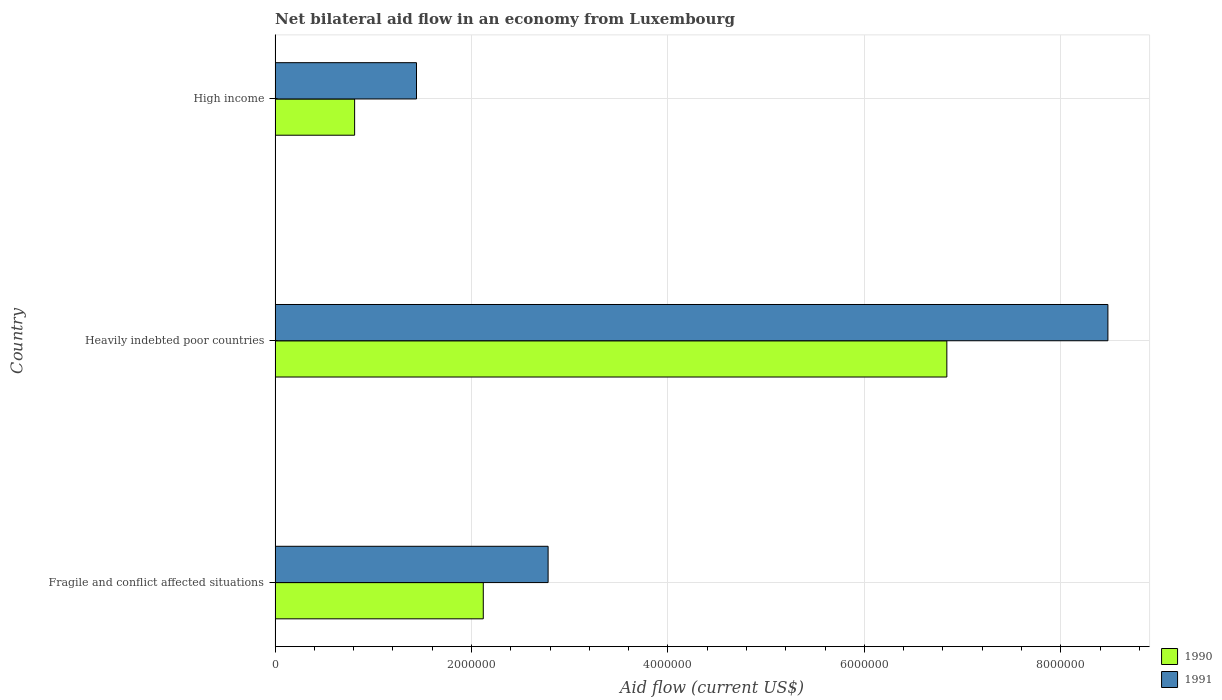Are the number of bars per tick equal to the number of legend labels?
Provide a succinct answer. Yes. How many bars are there on the 3rd tick from the bottom?
Your response must be concise. 2. What is the label of the 2nd group of bars from the top?
Provide a short and direct response. Heavily indebted poor countries. What is the net bilateral aid flow in 1990 in Fragile and conflict affected situations?
Provide a short and direct response. 2.12e+06. Across all countries, what is the maximum net bilateral aid flow in 1990?
Offer a terse response. 6.84e+06. Across all countries, what is the minimum net bilateral aid flow in 1990?
Your answer should be very brief. 8.10e+05. In which country was the net bilateral aid flow in 1990 maximum?
Make the answer very short. Heavily indebted poor countries. What is the total net bilateral aid flow in 1990 in the graph?
Your response must be concise. 9.77e+06. What is the difference between the net bilateral aid flow in 1991 in Fragile and conflict affected situations and that in High income?
Give a very brief answer. 1.34e+06. What is the difference between the net bilateral aid flow in 1990 in Fragile and conflict affected situations and the net bilateral aid flow in 1991 in High income?
Ensure brevity in your answer.  6.80e+05. What is the average net bilateral aid flow in 1991 per country?
Provide a succinct answer. 4.23e+06. What is the difference between the net bilateral aid flow in 1991 and net bilateral aid flow in 1990 in High income?
Your answer should be very brief. 6.30e+05. What is the ratio of the net bilateral aid flow in 1991 in Fragile and conflict affected situations to that in High income?
Offer a very short reply. 1.93. Is the difference between the net bilateral aid flow in 1991 in Heavily indebted poor countries and High income greater than the difference between the net bilateral aid flow in 1990 in Heavily indebted poor countries and High income?
Make the answer very short. Yes. What is the difference between the highest and the second highest net bilateral aid flow in 1990?
Give a very brief answer. 4.72e+06. What is the difference between the highest and the lowest net bilateral aid flow in 1991?
Your answer should be compact. 7.04e+06. What does the 1st bar from the bottom in High income represents?
Your answer should be compact. 1990. How many countries are there in the graph?
Make the answer very short. 3. Are the values on the major ticks of X-axis written in scientific E-notation?
Give a very brief answer. No. Does the graph contain grids?
Offer a very short reply. Yes. What is the title of the graph?
Provide a succinct answer. Net bilateral aid flow in an economy from Luxembourg. Does "1968" appear as one of the legend labels in the graph?
Provide a succinct answer. No. What is the label or title of the Y-axis?
Provide a succinct answer. Country. What is the Aid flow (current US$) of 1990 in Fragile and conflict affected situations?
Offer a terse response. 2.12e+06. What is the Aid flow (current US$) in 1991 in Fragile and conflict affected situations?
Make the answer very short. 2.78e+06. What is the Aid flow (current US$) in 1990 in Heavily indebted poor countries?
Give a very brief answer. 6.84e+06. What is the Aid flow (current US$) in 1991 in Heavily indebted poor countries?
Make the answer very short. 8.48e+06. What is the Aid flow (current US$) in 1990 in High income?
Make the answer very short. 8.10e+05. What is the Aid flow (current US$) of 1991 in High income?
Your answer should be very brief. 1.44e+06. Across all countries, what is the maximum Aid flow (current US$) of 1990?
Your response must be concise. 6.84e+06. Across all countries, what is the maximum Aid flow (current US$) of 1991?
Give a very brief answer. 8.48e+06. Across all countries, what is the minimum Aid flow (current US$) of 1990?
Your response must be concise. 8.10e+05. Across all countries, what is the minimum Aid flow (current US$) in 1991?
Offer a terse response. 1.44e+06. What is the total Aid flow (current US$) of 1990 in the graph?
Provide a short and direct response. 9.77e+06. What is the total Aid flow (current US$) of 1991 in the graph?
Keep it short and to the point. 1.27e+07. What is the difference between the Aid flow (current US$) in 1990 in Fragile and conflict affected situations and that in Heavily indebted poor countries?
Ensure brevity in your answer.  -4.72e+06. What is the difference between the Aid flow (current US$) of 1991 in Fragile and conflict affected situations and that in Heavily indebted poor countries?
Make the answer very short. -5.70e+06. What is the difference between the Aid flow (current US$) of 1990 in Fragile and conflict affected situations and that in High income?
Your response must be concise. 1.31e+06. What is the difference between the Aid flow (current US$) of 1991 in Fragile and conflict affected situations and that in High income?
Offer a terse response. 1.34e+06. What is the difference between the Aid flow (current US$) in 1990 in Heavily indebted poor countries and that in High income?
Give a very brief answer. 6.03e+06. What is the difference between the Aid flow (current US$) in 1991 in Heavily indebted poor countries and that in High income?
Provide a succinct answer. 7.04e+06. What is the difference between the Aid flow (current US$) in 1990 in Fragile and conflict affected situations and the Aid flow (current US$) in 1991 in Heavily indebted poor countries?
Keep it short and to the point. -6.36e+06. What is the difference between the Aid flow (current US$) in 1990 in Fragile and conflict affected situations and the Aid flow (current US$) in 1991 in High income?
Make the answer very short. 6.80e+05. What is the difference between the Aid flow (current US$) of 1990 in Heavily indebted poor countries and the Aid flow (current US$) of 1991 in High income?
Ensure brevity in your answer.  5.40e+06. What is the average Aid flow (current US$) in 1990 per country?
Provide a short and direct response. 3.26e+06. What is the average Aid flow (current US$) in 1991 per country?
Your answer should be compact. 4.23e+06. What is the difference between the Aid flow (current US$) of 1990 and Aid flow (current US$) of 1991 in Fragile and conflict affected situations?
Provide a short and direct response. -6.60e+05. What is the difference between the Aid flow (current US$) in 1990 and Aid flow (current US$) in 1991 in Heavily indebted poor countries?
Your response must be concise. -1.64e+06. What is the difference between the Aid flow (current US$) in 1990 and Aid flow (current US$) in 1991 in High income?
Your answer should be very brief. -6.30e+05. What is the ratio of the Aid flow (current US$) of 1990 in Fragile and conflict affected situations to that in Heavily indebted poor countries?
Offer a very short reply. 0.31. What is the ratio of the Aid flow (current US$) of 1991 in Fragile and conflict affected situations to that in Heavily indebted poor countries?
Make the answer very short. 0.33. What is the ratio of the Aid flow (current US$) of 1990 in Fragile and conflict affected situations to that in High income?
Your answer should be compact. 2.62. What is the ratio of the Aid flow (current US$) of 1991 in Fragile and conflict affected situations to that in High income?
Make the answer very short. 1.93. What is the ratio of the Aid flow (current US$) in 1990 in Heavily indebted poor countries to that in High income?
Provide a succinct answer. 8.44. What is the ratio of the Aid flow (current US$) in 1991 in Heavily indebted poor countries to that in High income?
Your answer should be very brief. 5.89. What is the difference between the highest and the second highest Aid flow (current US$) in 1990?
Your response must be concise. 4.72e+06. What is the difference between the highest and the second highest Aid flow (current US$) in 1991?
Your answer should be very brief. 5.70e+06. What is the difference between the highest and the lowest Aid flow (current US$) of 1990?
Keep it short and to the point. 6.03e+06. What is the difference between the highest and the lowest Aid flow (current US$) in 1991?
Your answer should be very brief. 7.04e+06. 